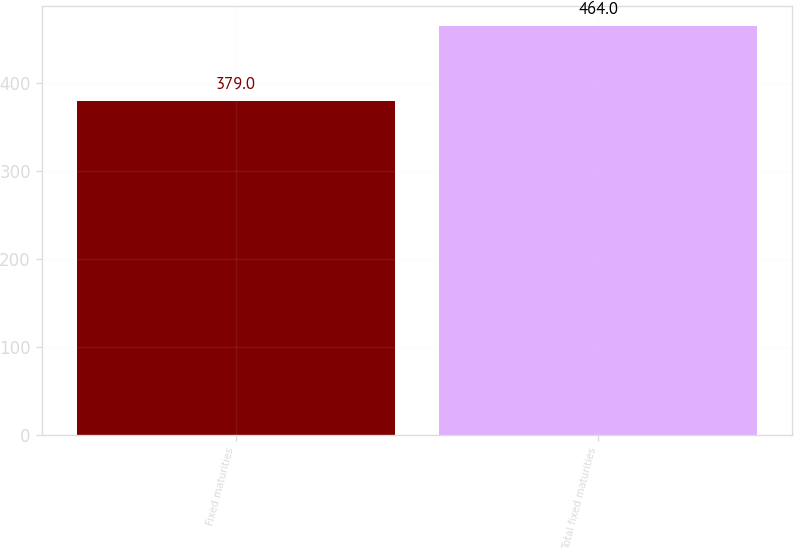Convert chart to OTSL. <chart><loc_0><loc_0><loc_500><loc_500><bar_chart><fcel>Fixed maturities<fcel>Total fixed maturities<nl><fcel>379<fcel>464<nl></chart> 